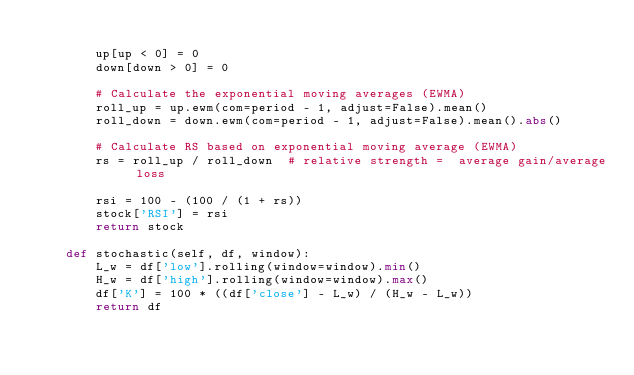Convert code to text. <code><loc_0><loc_0><loc_500><loc_500><_Python_>
        up[up < 0] = 0
        down[down > 0] = 0

        # Calculate the exponential moving averages (EWMA)
        roll_up = up.ewm(com=period - 1, adjust=False).mean()
        roll_down = down.ewm(com=period - 1, adjust=False).mean().abs()

        # Calculate RS based on exponential moving average (EWMA)
        rs = roll_up / roll_down  # relative strength =  average gain/average loss

        rsi = 100 - (100 / (1 + rs))
        stock['RSI'] = rsi
        return stock

    def stochastic(self, df, window):
        L_w = df['low'].rolling(window=window).min()
        H_w = df['high'].rolling(window=window).max()
        df['K'] = 100 * ((df['close'] - L_w) / (H_w - L_w))
        return df
</code> 